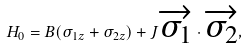Convert formula to latex. <formula><loc_0><loc_0><loc_500><loc_500>H _ { 0 } = B ( { \sigma _ { 1 z } } + { \sigma _ { 2 z } } ) + J \overrightarrow { \sigma _ { 1 } } \cdot \overrightarrow { \sigma _ { 2 } } ,</formula> 